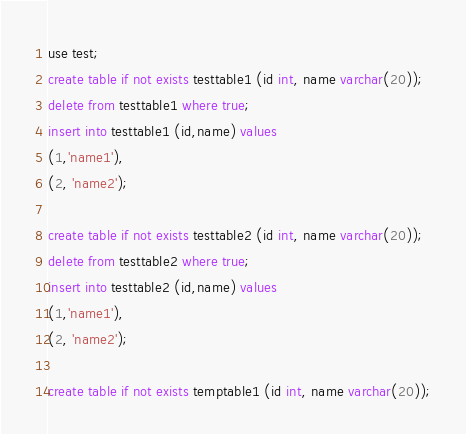Convert code to text. <code><loc_0><loc_0><loc_500><loc_500><_SQL_>use test;
create table if not exists testtable1 (id int, name varchar(20));
delete from testtable1 where true;
insert into testtable1 (id,name) values 
(1,'name1'), 
(2, 'name2');

create table if not exists testtable2 (id int, name varchar(20));
delete from testtable2 where true;
insert into testtable2 (id,name) values 
(1,'name1'), 
(2, 'name2');

create table if not exists temptable1 (id int, name varchar(20));
</code> 